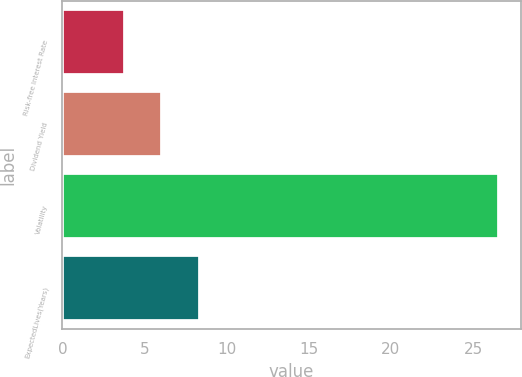Convert chart. <chart><loc_0><loc_0><loc_500><loc_500><bar_chart><fcel>Risk-free Interest Rate<fcel>Dividend Yield<fcel>Volatility<fcel>ExpectedLives(Years)<nl><fcel>3.82<fcel>6.09<fcel>26.57<fcel>8.37<nl></chart> 